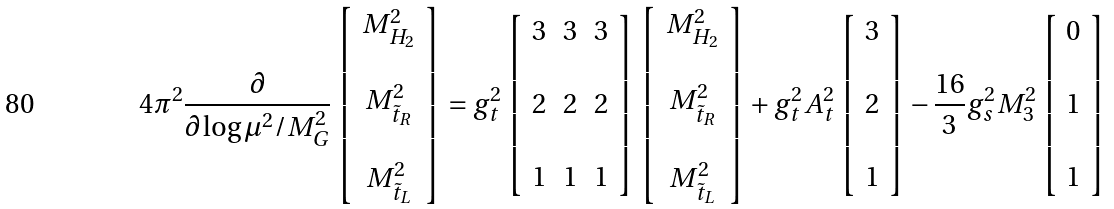Convert formula to latex. <formula><loc_0><loc_0><loc_500><loc_500>4 \pi ^ { 2 } \frac { \partial } { \partial \log \mu ^ { 2 } / M _ { G } ^ { 2 } } \left [ \begin{array} { c } M _ { H _ { 2 } } ^ { 2 } \\ \\ M _ { \tilde { t } _ { R } } ^ { 2 } \\ \\ M _ { \tilde { t } _ { L } } ^ { 2 } \end{array} \right ] = g _ { t } ^ { 2 } \left [ \begin{array} { c c c } 3 & 3 & 3 \\ \\ 2 & 2 & 2 \\ \\ 1 & 1 & 1 \end{array} \right ] \left [ \begin{array} { c } M _ { H _ { 2 } } ^ { 2 } \\ \\ M _ { \tilde { t } _ { R } } ^ { 2 } \\ \\ M _ { \tilde { t } _ { L } } ^ { 2 } \end{array} \right ] + g _ { t } ^ { 2 } A _ { t } ^ { 2 } \left [ \begin{array} { c } 3 \\ \\ 2 \\ \\ 1 \end{array} \right ] - \frac { 1 6 } { 3 } g _ { s } ^ { 2 } M _ { 3 } ^ { 2 } \left [ \begin{array} { c } 0 \\ \\ 1 \\ \\ 1 \end{array} \right ]</formula> 